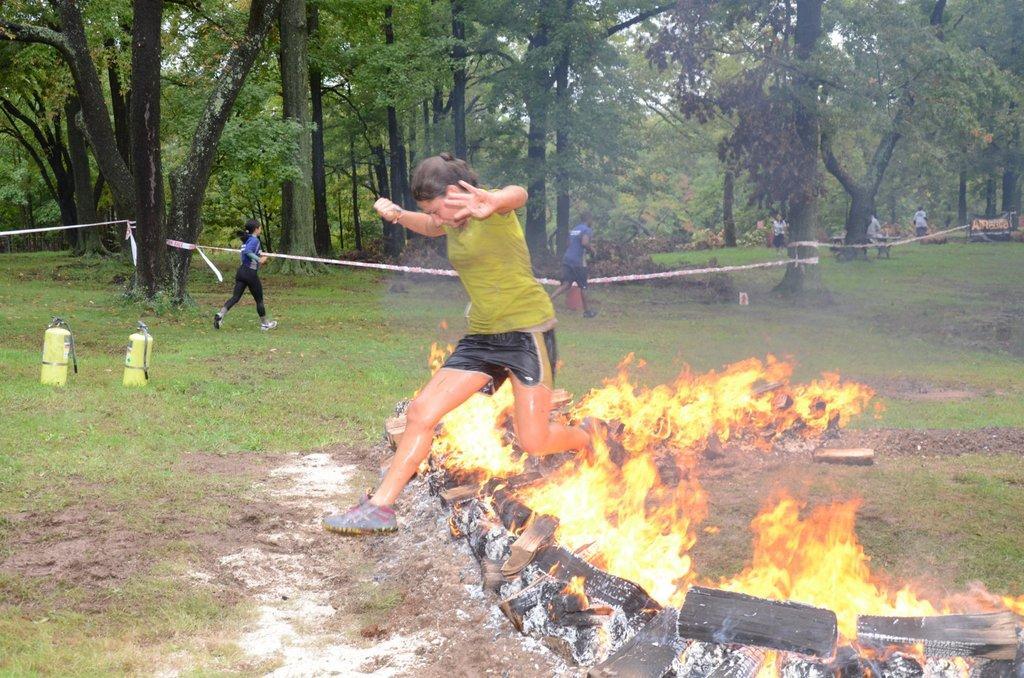Describe this image in one or two sentences. In the foreground of this picture, there is a woman jumping up from a fire. In the background, there are persons running, grass, cylinders and trees. 